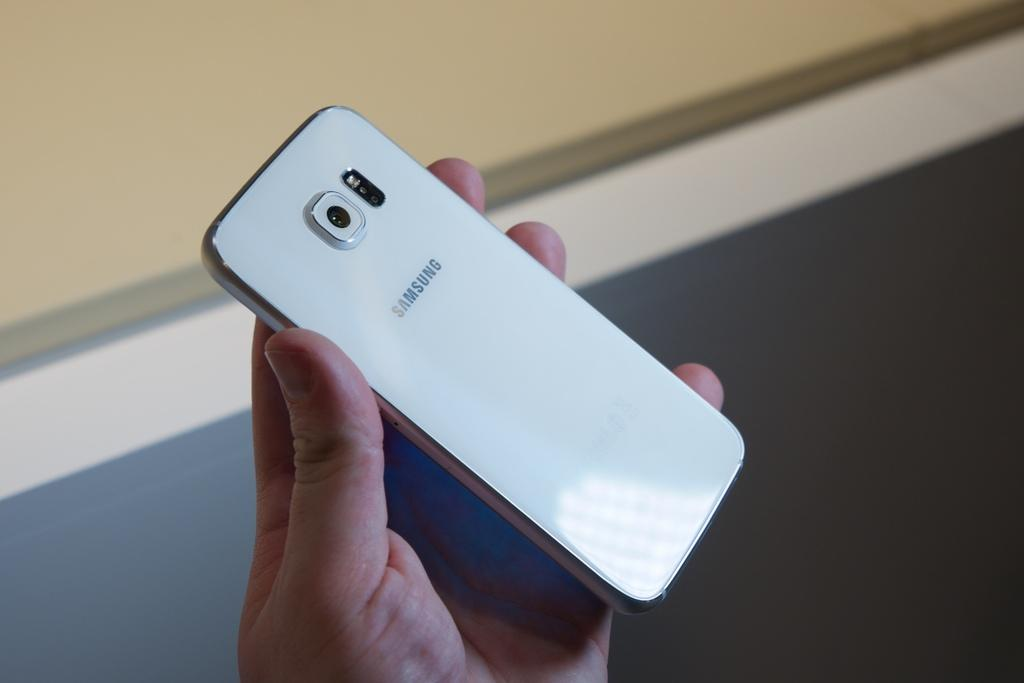<image>
Give a short and clear explanation of the subsequent image. A hand is holding the back side of a Samsung smart phone. 